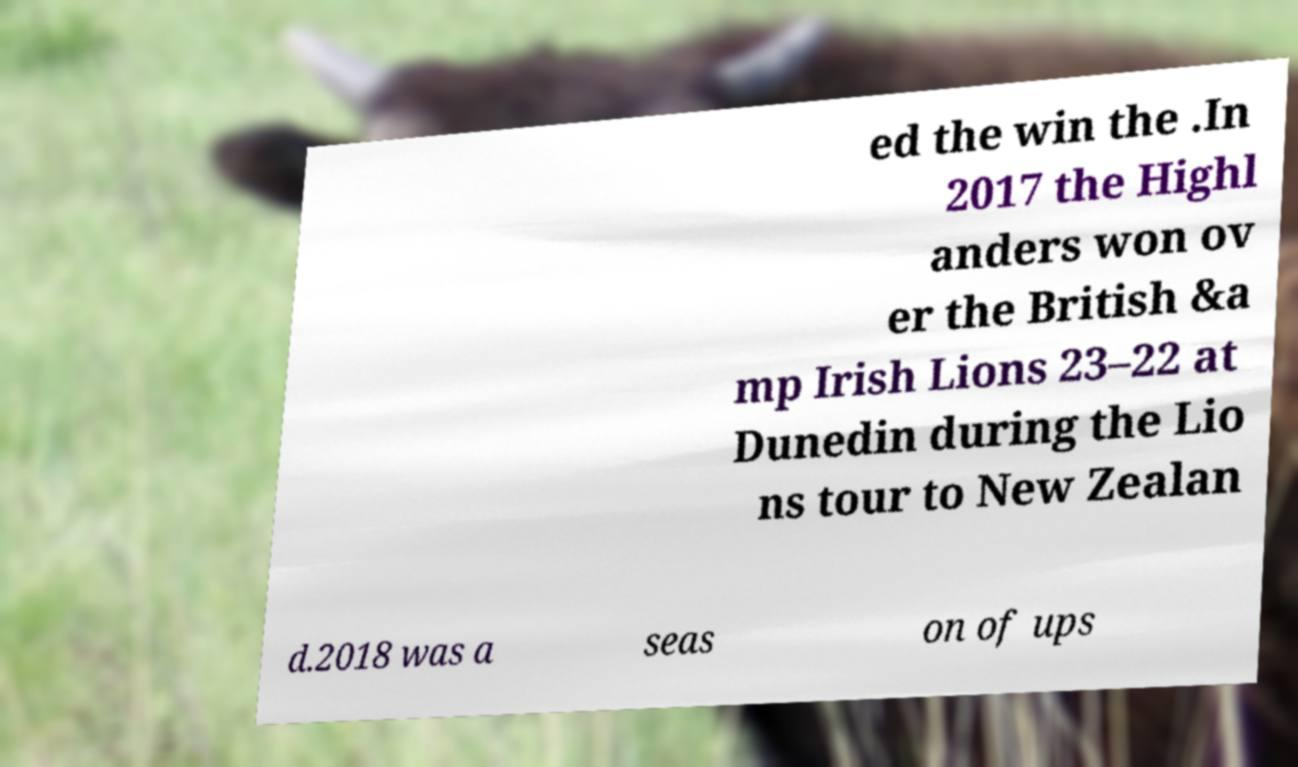What messages or text are displayed in this image? I need them in a readable, typed format. ed the win the .In 2017 the Highl anders won ov er the British &a mp Irish Lions 23–22 at Dunedin during the Lio ns tour to New Zealan d.2018 was a seas on of ups 